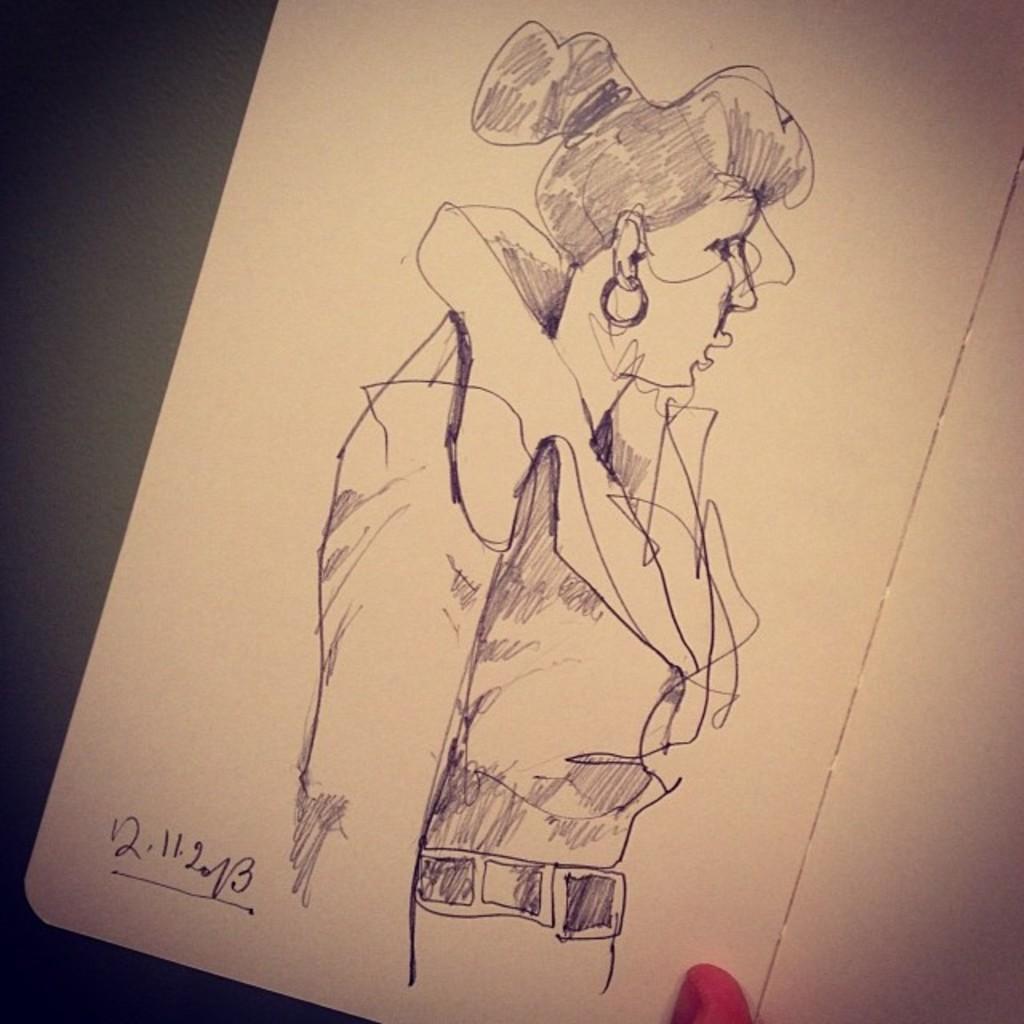How would you summarize this image in a sentence or two? In this image there is one book and in the book there is a drawing and some text. At the bottom there is one person's finger is visible, and in the background it looks like a table. 